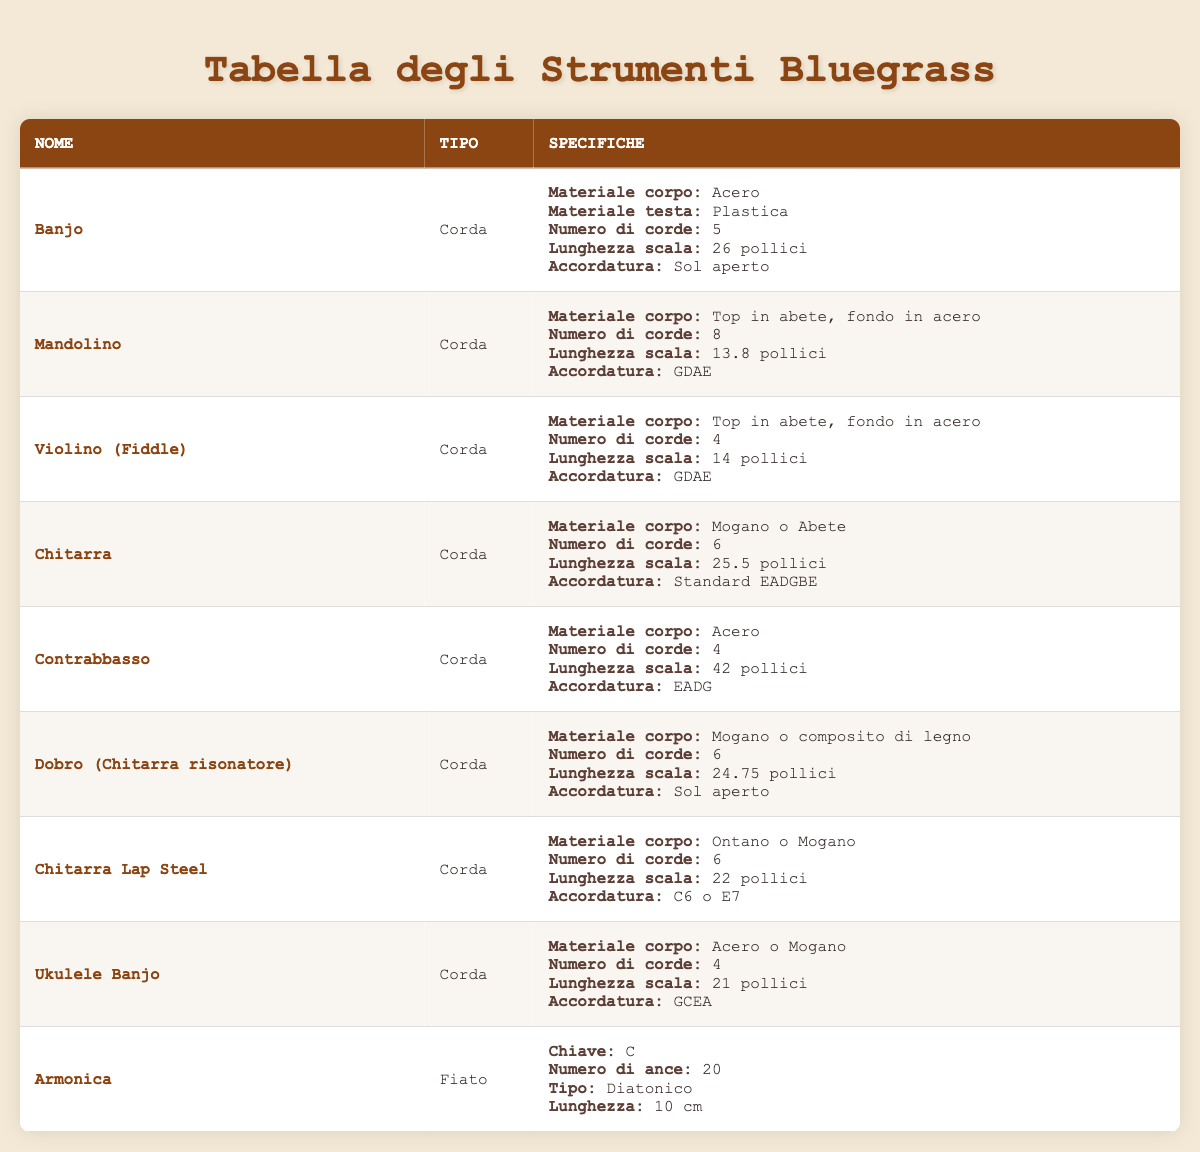What is the body material of the Banjo? The table shows that the body material of the Banjo is Maple.
Answer: Maple How many strings does a Mandolin have? According to the specifications in the table, the Mandolin has 8 strings.
Answer: 8 What is the scale length of the Fiddle? The table indicates that the scale length of the Fiddle (Violin) is 14 inches.
Answer: 14 inches Which instrument has the highest number of strings? By examining the table, the Mandolin has the highest number of strings, which is 8, compared to all other instruments listed.
Answer: Mandolin Is the body material for the Dobro the same as the Lap Steel Guitar? The table reveals that the Dobro has a body material of Mahogany or wood composite, while the Lap Steel Guitar has a body material of Alder or Mahogany. Therefore, the body materials are not the same.
Answer: No What is the average scale length of all string instruments listed? The scale lengths of the string instruments are 26, 13.8, 14, 25.5, 42, 24.75, 22, 21 inches. To find the average, sum these lengths (26 + 13.8 + 14 + 25.5 + 42 + 24.75 + 22 + 21) = 189.05. There are 8 instruments, so the average scale length is 189.05 / 8 = 23.63 inches.
Answer: 23.63 inches Does the Bass (Upright Bass) have more strings than the Fiddle? The table lists the Bass (Upright Bass) with 4 strings and the Fiddle with also 4 strings. Therefore, they have the same number of strings.
Answer: No What tuning does the Guitar use? The specifications in the table indicate that the Guitar is tuned to Standard EADGBE.
Answer: Standard EADGBE Which instrument has the least number of strings? Looking at the table, both the Banjo Ukulele and the Fiddle have 4 strings, making them the instruments with the least number of strings in this list.
Answer: Banjo Ukulele and Fiddle 